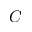Convert formula to latex. <formula><loc_0><loc_0><loc_500><loc_500>C</formula> 